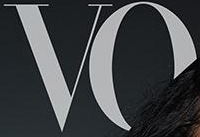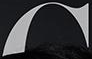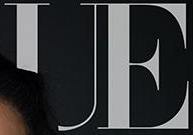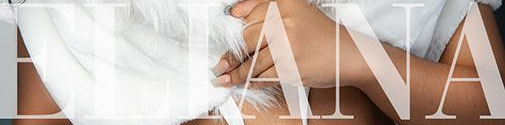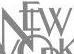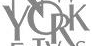Read the text content from these images in order, separated by a semicolon. VO; #; UE; ELIANA; NEW; YORK 